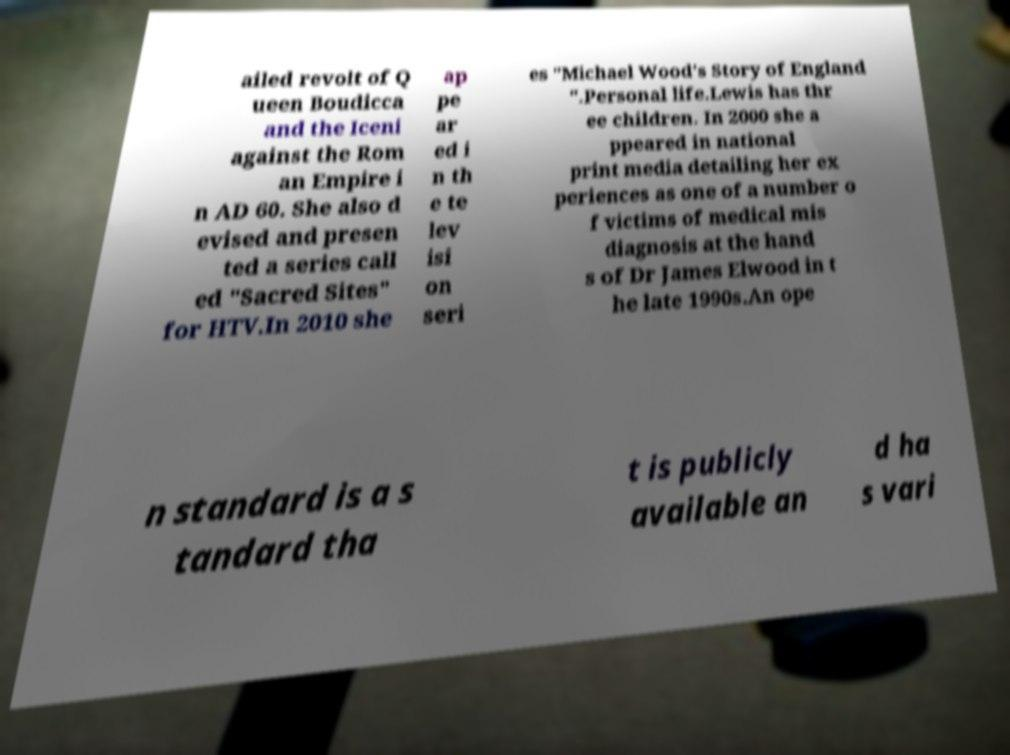What messages or text are displayed in this image? I need them in a readable, typed format. ailed revolt of Q ueen Boudicca and the Iceni against the Rom an Empire i n AD 60. She also d evised and presen ted a series call ed "Sacred Sites" for HTV.In 2010 she ap pe ar ed i n th e te lev isi on seri es "Michael Wood's Story of England ".Personal life.Lewis has thr ee children. In 2000 she a ppeared in national print media detailing her ex periences as one of a number o f victims of medical mis diagnosis at the hand s of Dr James Elwood in t he late 1990s.An ope n standard is a s tandard tha t is publicly available an d ha s vari 